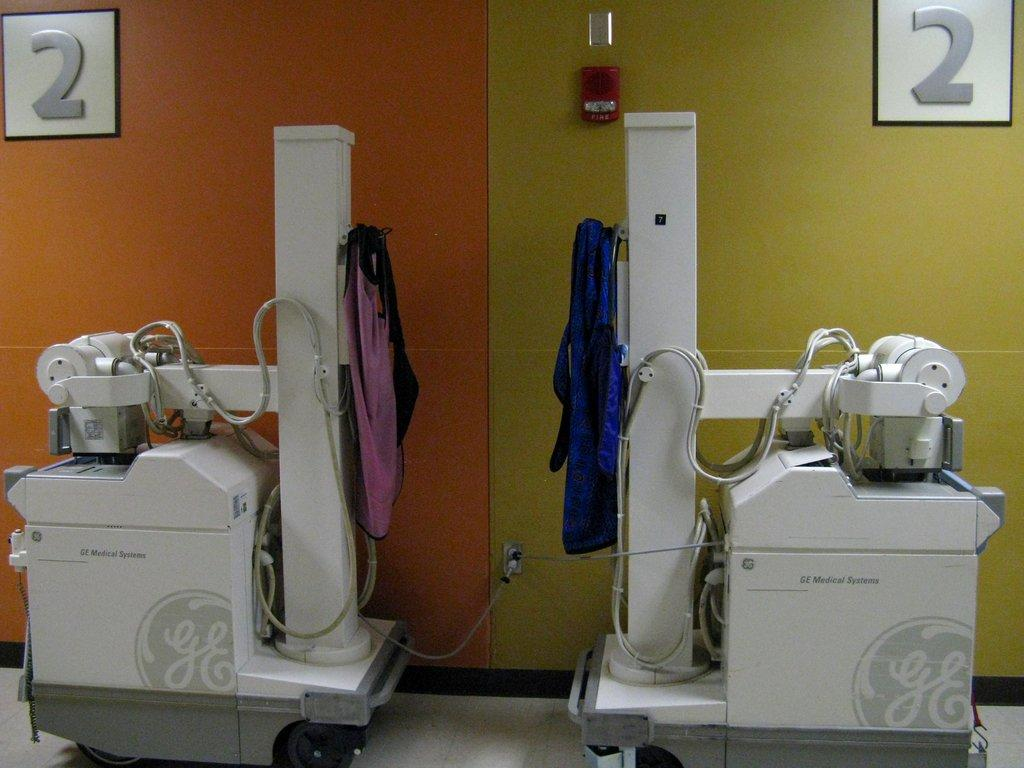What can be seen in the foreground of the picture? In the foreground of the picture, there are machines, cables, and cloth. What is located in the background of the picture? In the background of the picture, there is a wall with posters and a fire alarm. What type of objects are attached to the wall in the background? The wall in the background has posters and a fire alarm attached to it. Can you see a dog tying a knot with the cables in the foreground of the image? No, there is no dog or knot-tying activity present in the image. Who is the expert in the picture, and what are they doing? There is no expert or specific activity being performed by anyone in the image. 